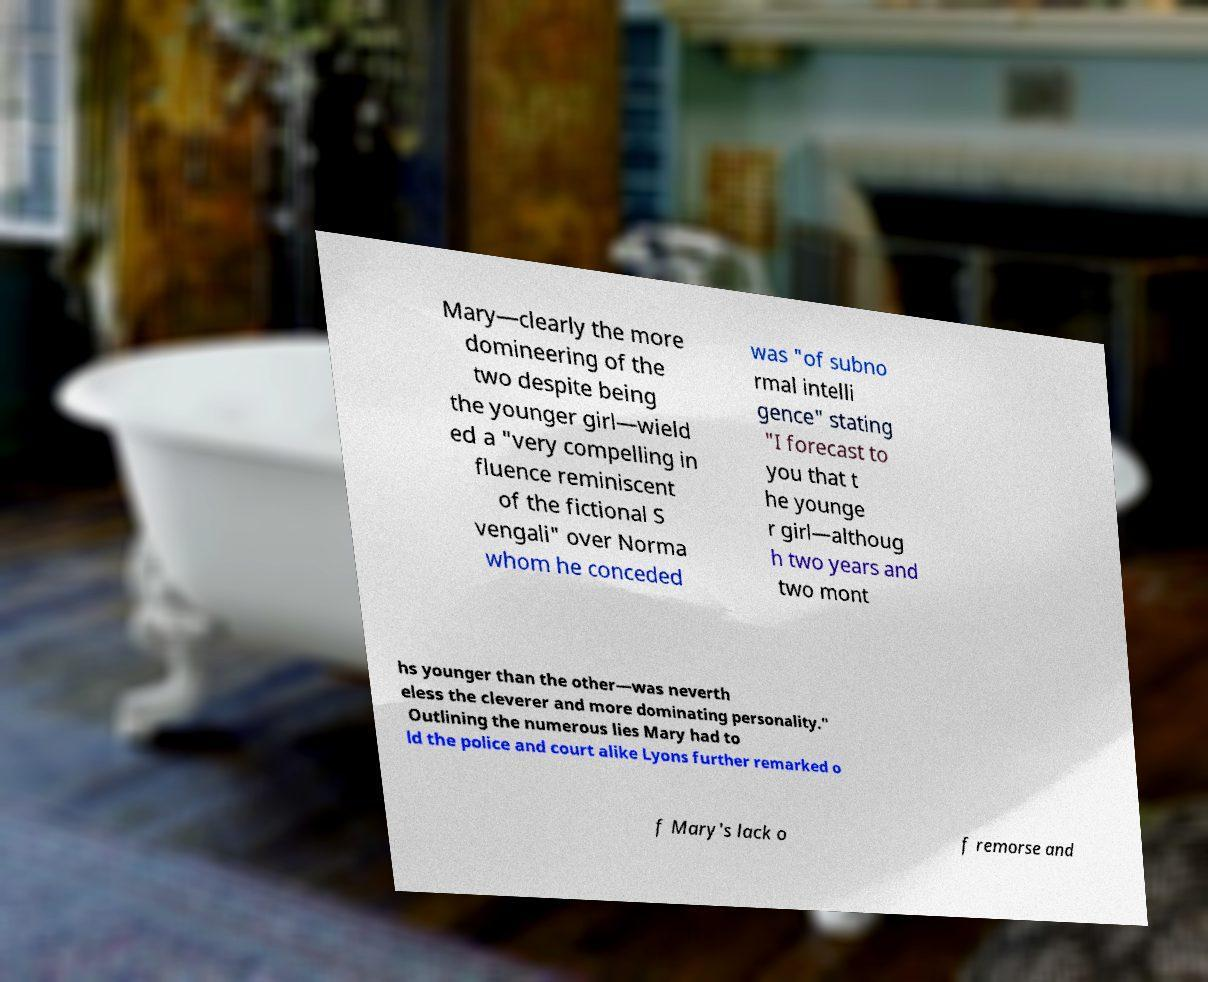There's text embedded in this image that I need extracted. Can you transcribe it verbatim? Mary—clearly the more domineering of the two despite being the younger girl—wield ed a "very compelling in fluence reminiscent of the fictional S vengali" over Norma whom he conceded was "of subno rmal intelli gence" stating "I forecast to you that t he younge r girl—althoug h two years and two mont hs younger than the other—was neverth eless the cleverer and more dominating personality." Outlining the numerous lies Mary had to ld the police and court alike Lyons further remarked o f Mary's lack o f remorse and 